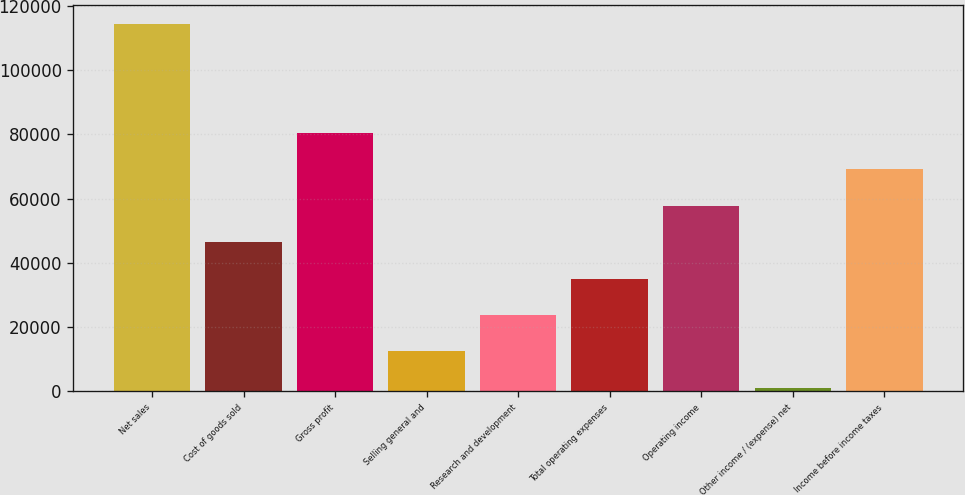<chart> <loc_0><loc_0><loc_500><loc_500><bar_chart><fcel>Net sales<fcel>Cost of goods sold<fcel>Gross profit<fcel>Selling general and<fcel>Research and development<fcel>Total operating expenses<fcel>Operating income<fcel>Other income / (expense) net<fcel>Income before income taxes<nl><fcel>114470<fcel>46389.2<fcel>80429.6<fcel>12348.8<fcel>23695.6<fcel>35042.4<fcel>57736<fcel>1002<fcel>69082.8<nl></chart> 